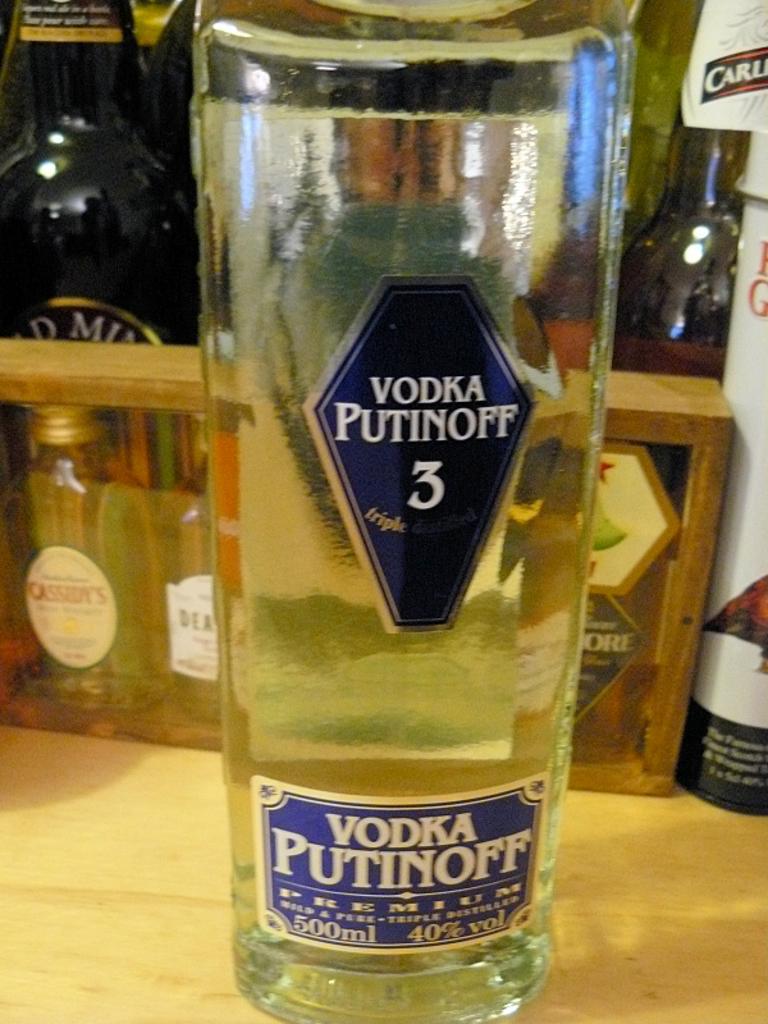Could you give a brief overview of what you see in this image? In this image we can see a vodka bottle with a label on it placed on the table. In the background we can see bottles. 